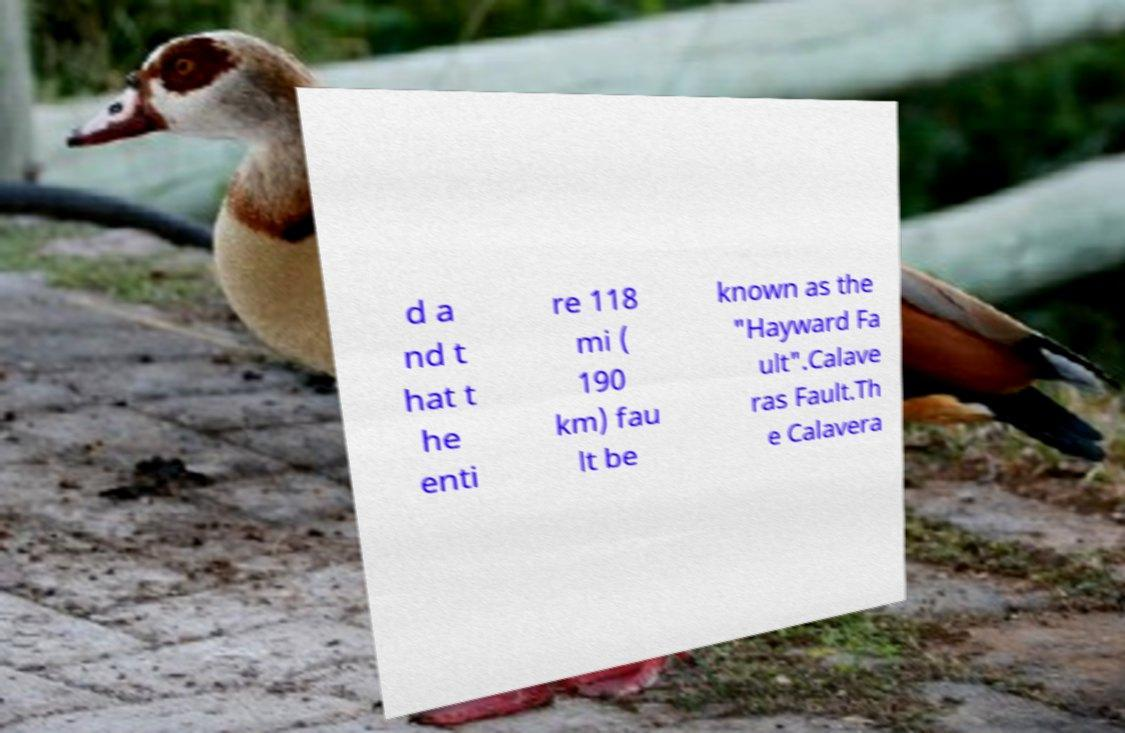What messages or text are displayed in this image? I need them in a readable, typed format. d a nd t hat t he enti re 118 mi ( 190 km) fau lt be known as the "Hayward Fa ult".Calave ras Fault.Th e Calavera 